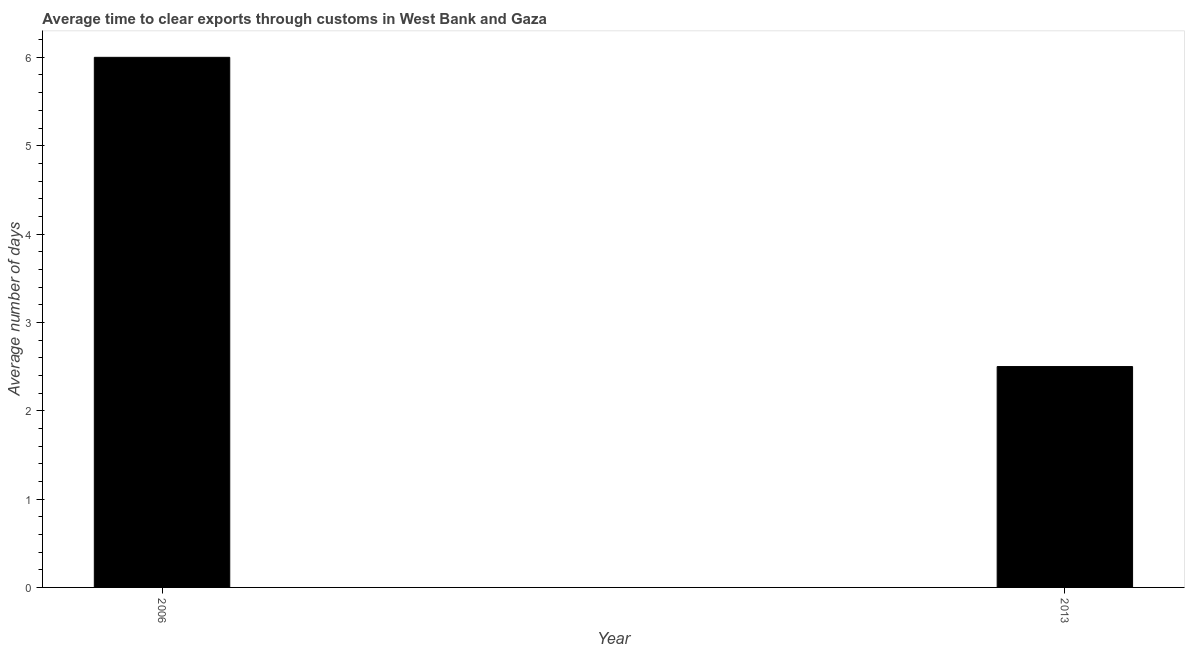Does the graph contain any zero values?
Give a very brief answer. No. What is the title of the graph?
Offer a very short reply. Average time to clear exports through customs in West Bank and Gaza. What is the label or title of the X-axis?
Give a very brief answer. Year. What is the label or title of the Y-axis?
Make the answer very short. Average number of days. What is the time to clear exports through customs in 2013?
Give a very brief answer. 2.5. Across all years, what is the maximum time to clear exports through customs?
Give a very brief answer. 6. Across all years, what is the minimum time to clear exports through customs?
Offer a terse response. 2.5. In which year was the time to clear exports through customs minimum?
Your response must be concise. 2013. What is the average time to clear exports through customs per year?
Your response must be concise. 4.25. What is the median time to clear exports through customs?
Your answer should be very brief. 4.25. What is the ratio of the time to clear exports through customs in 2006 to that in 2013?
Give a very brief answer. 2.4. Is the time to clear exports through customs in 2006 less than that in 2013?
Ensure brevity in your answer.  No. Are all the bars in the graph horizontal?
Your answer should be very brief. No. Are the values on the major ticks of Y-axis written in scientific E-notation?
Your response must be concise. No. What is the Average number of days of 2006?
Your answer should be compact. 6. What is the difference between the Average number of days in 2006 and 2013?
Give a very brief answer. 3.5. 